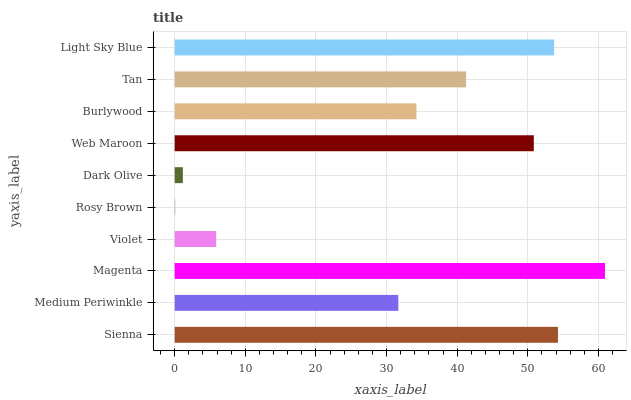Is Rosy Brown the minimum?
Answer yes or no. Yes. Is Magenta the maximum?
Answer yes or no. Yes. Is Medium Periwinkle the minimum?
Answer yes or no. No. Is Medium Periwinkle the maximum?
Answer yes or no. No. Is Sienna greater than Medium Periwinkle?
Answer yes or no. Yes. Is Medium Periwinkle less than Sienna?
Answer yes or no. Yes. Is Medium Periwinkle greater than Sienna?
Answer yes or no. No. Is Sienna less than Medium Periwinkle?
Answer yes or no. No. Is Tan the high median?
Answer yes or no. Yes. Is Burlywood the low median?
Answer yes or no. Yes. Is Burlywood the high median?
Answer yes or no. No. Is Web Maroon the low median?
Answer yes or no. No. 